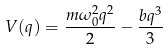<formula> <loc_0><loc_0><loc_500><loc_500>V ( q ) = \frac { m \omega _ { 0 } ^ { 2 } q ^ { 2 } } { 2 } - \frac { b q ^ { 3 } } { 3 }</formula> 